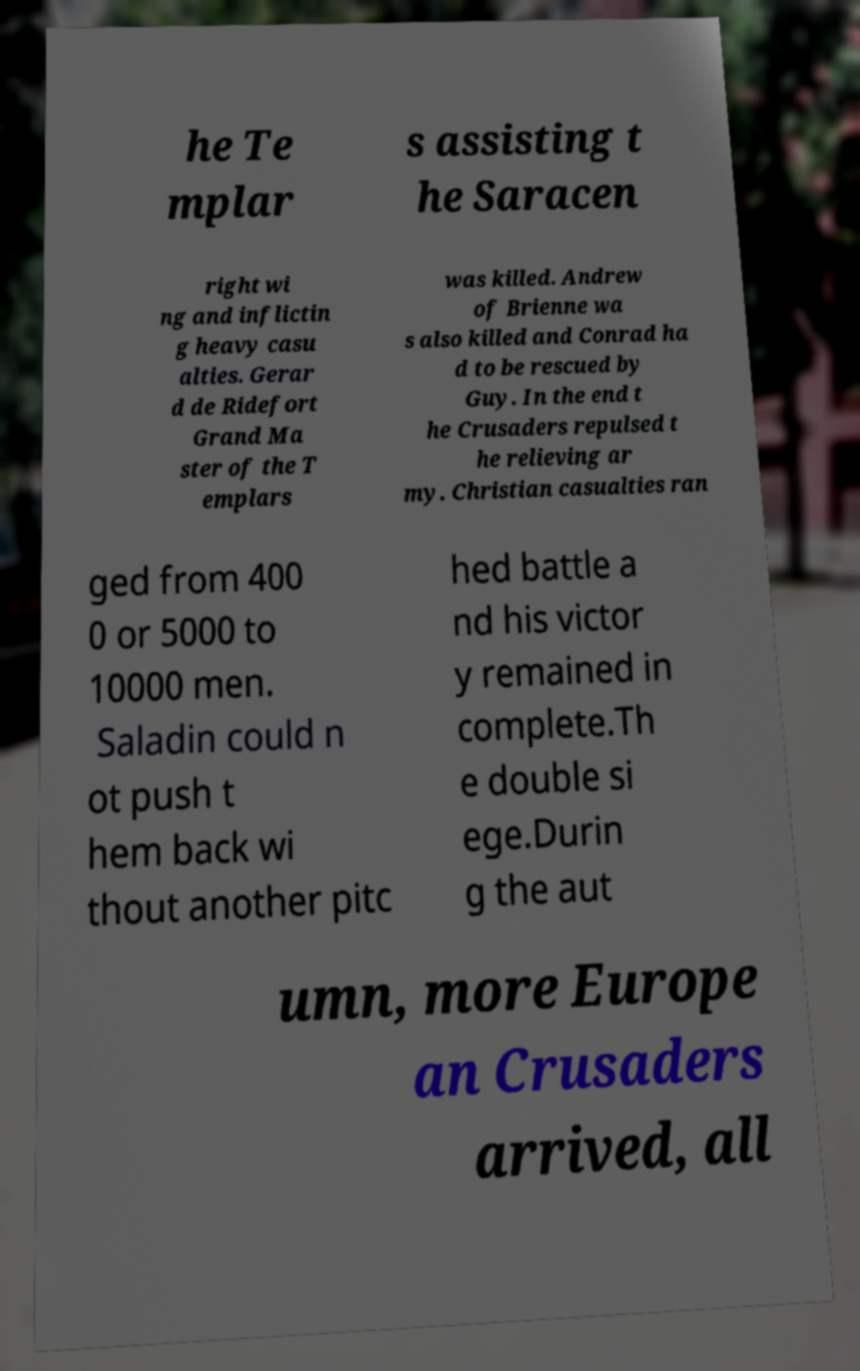Could you extract and type out the text from this image? he Te mplar s assisting t he Saracen right wi ng and inflictin g heavy casu alties. Gerar d de Ridefort Grand Ma ster of the T emplars was killed. Andrew of Brienne wa s also killed and Conrad ha d to be rescued by Guy. In the end t he Crusaders repulsed t he relieving ar my. Christian casualties ran ged from 400 0 or 5000 to 10000 men. Saladin could n ot push t hem back wi thout another pitc hed battle a nd his victor y remained in complete.Th e double si ege.Durin g the aut umn, more Europe an Crusaders arrived, all 